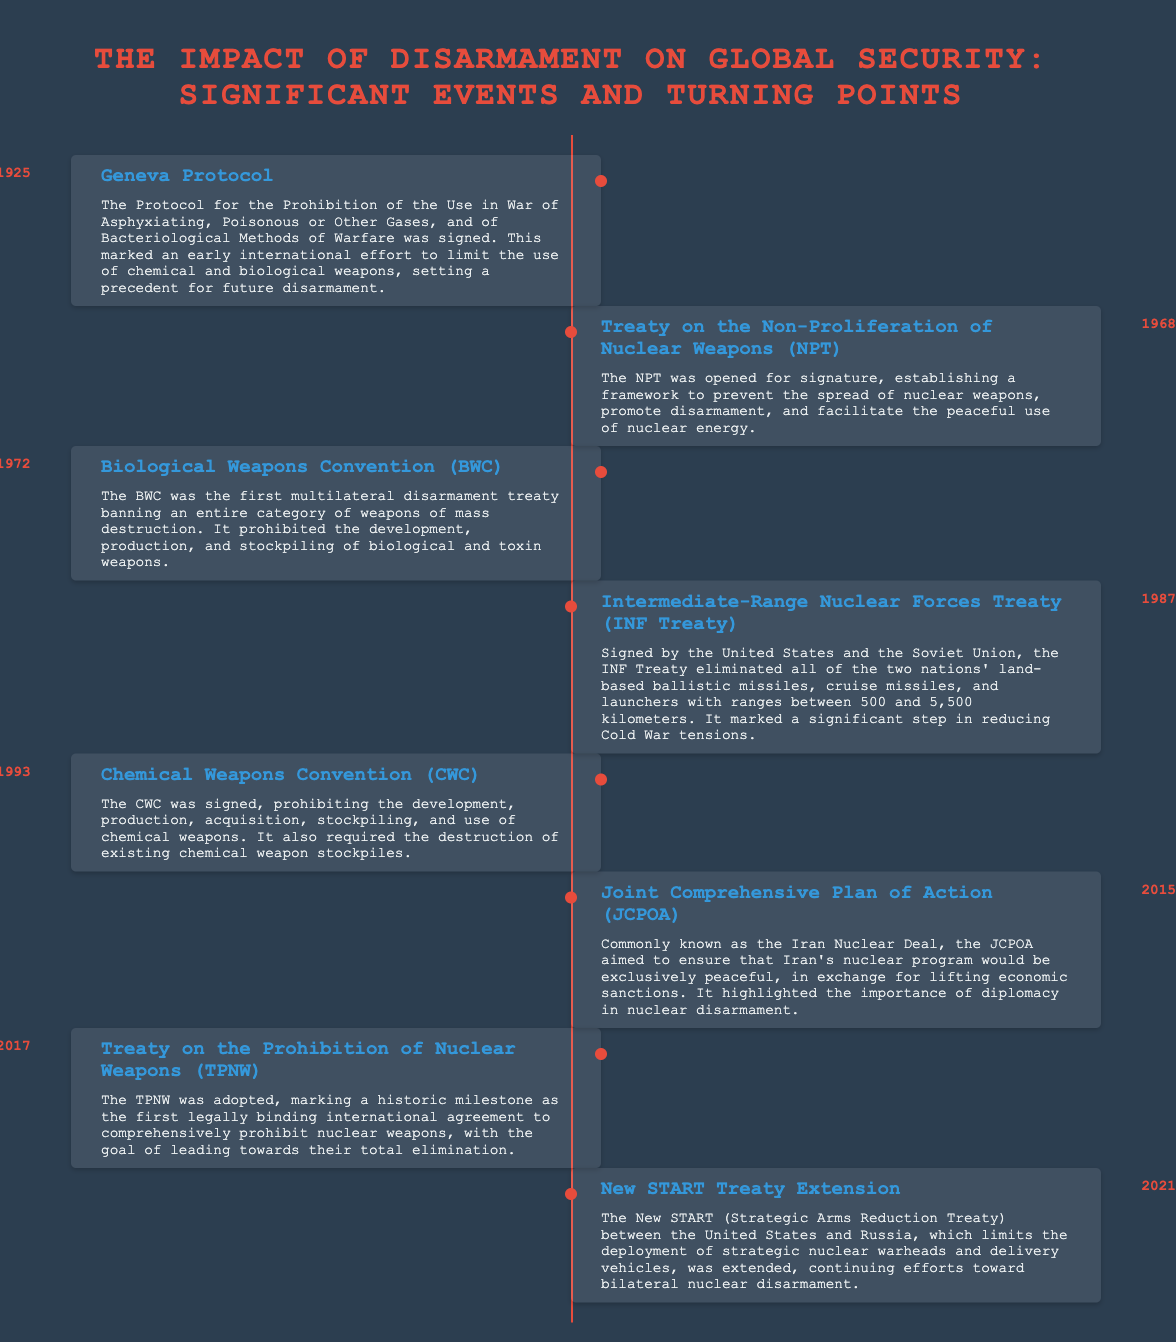What year was the Geneva Protocol signed? The Geneva Protocol was signed in 1925, as stated in the document.
Answer: 1925 What treaty aimed to prohibit chemical weapons? The document states that the Chemical Weapons Convention (CWC) prohibits the development, production, acquisition, stockpiling, and use of chemical weapons.
Answer: Chemical Weapons Convention (CWC) Which treaty eliminated land-based missiles between the US and the Soviet Union? According to the timeline, the Intermediate-Range Nuclear Forces Treaty (INF Treaty) specifically eliminated these land-based missiles.
Answer: Intermediate-Range Nuclear Forces Treaty (INF Treaty) Which event marks the first legally binding agreement to prohibit nuclear weapons? The timeline highlights the Treaty on the Prohibition of Nuclear Weapons (TPNW) as the first such agreement.
Answer: Treaty on the Prohibition of Nuclear Weapons (TPNW) How many significant disarmament events are listed in the timeline? The document lists eight significant events related to disarmament, as seen in the infographic.
Answer: Eight What was the purpose of the Joint Comprehensive Plan of Action (JCPOA)? The JCPOA aimed to ensure that Iran's nuclear program would be exclusively peaceful, as mentioned in the timeline.
Answer: Ensure peaceful nuclear program What does the New START Treaty limit? The New START Treaty limits the deployment of strategic nuclear warheads and delivery vehicles, according to the information provided in the document.
Answer: Strategic nuclear warheads and delivery vehicles What year was the Treaty on the Non-Proliferation of Nuclear Weapons opened for signature? The timeline specifies that the NPT was opened for signature in 1968.
Answer: 1968 Which treaty is the first multilateral disarmament treaty banning biological weapons? The Biological Weapons Convention (BWC) is identified in the document as the first multilateral disarmament treaty banning biological weapons.
Answer: Biological Weapons Convention (BWC) 